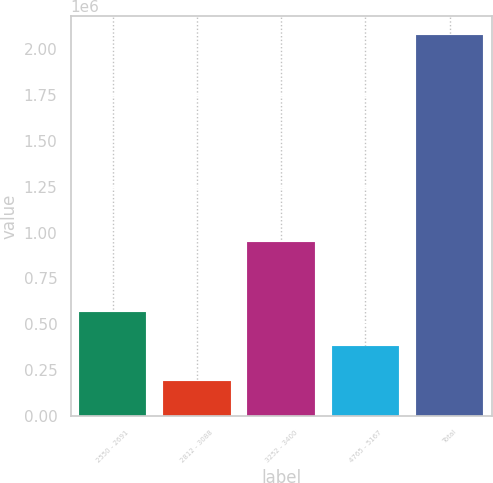Convert chart. <chart><loc_0><loc_0><loc_500><loc_500><bar_chart><fcel>2550 - 2691<fcel>2812 - 3088<fcel>3252 - 3400<fcel>4765 - 5167<fcel>Total<nl><fcel>567769<fcel>189685<fcel>949555<fcel>379244<fcel>2.07493e+06<nl></chart> 